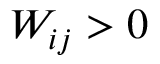<formula> <loc_0><loc_0><loc_500><loc_500>W _ { i j } > 0</formula> 